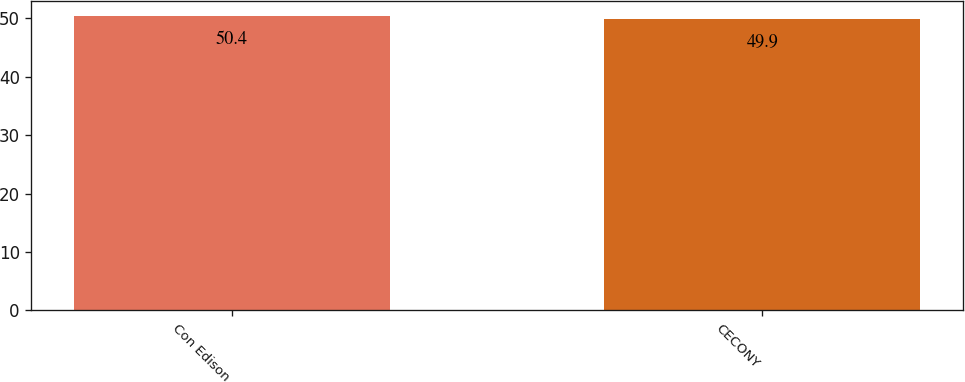<chart> <loc_0><loc_0><loc_500><loc_500><bar_chart><fcel>Con Edison<fcel>CECONY<nl><fcel>50.4<fcel>49.9<nl></chart> 